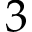<formula> <loc_0><loc_0><loc_500><loc_500>3</formula> 